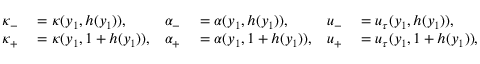Convert formula to latex. <formula><loc_0><loc_0><loc_500><loc_500>\begin{array} { r l r l r l } { \kappa _ { - } } & = \kappa ( y _ { 1 } , h ( y _ { 1 } ) ) , } & { \alpha _ { - } } & = \alpha ( y _ { 1 } , h ( y _ { 1 } ) ) , } & { u _ { - } } & = u _ { \tau } ( y _ { 1 } , h ( y _ { 1 } ) ) , } \\ { \kappa _ { + } } & = \kappa ( y _ { 1 } , 1 + h ( y _ { 1 } ) ) , } & { \alpha _ { + } } & = \alpha ( y _ { 1 } , 1 + h ( y _ { 1 } ) ) , } & { u _ { + } } & = u _ { \tau } ( y _ { 1 } , 1 + h ( y _ { 1 } ) ) , } \end{array}</formula> 